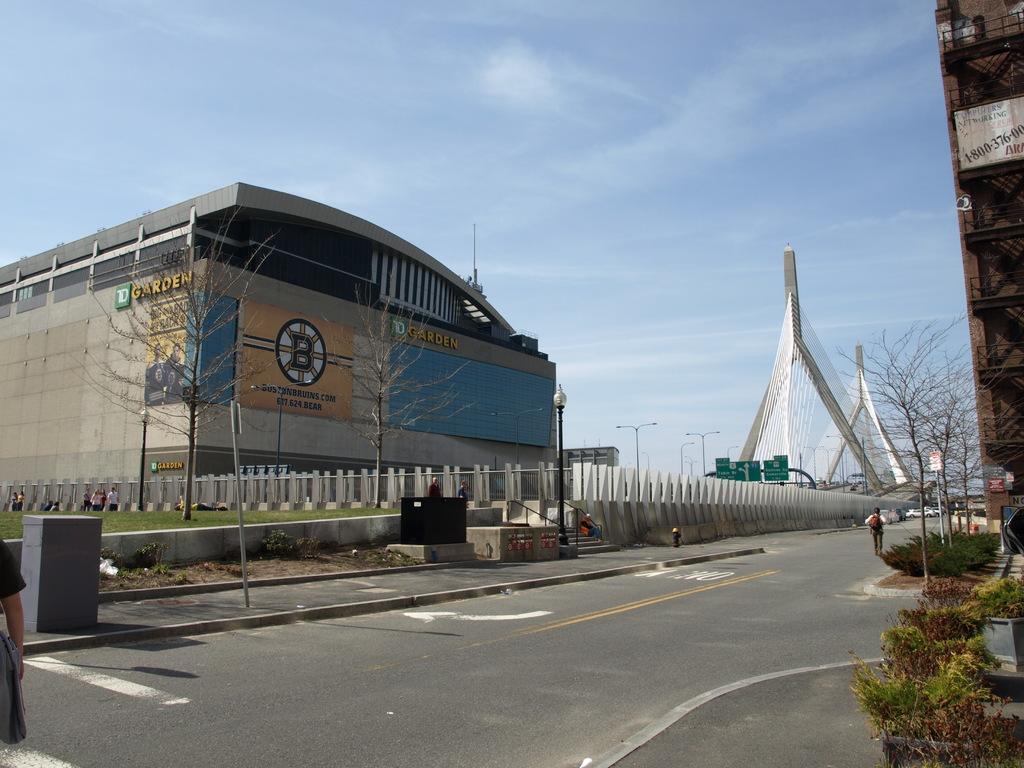Describe this image in one or two sentences. In this image we can see a building and some text written on it, some people in front of the building, a road and a person walking on the road, there are some trees and plants, sign boards and street lights and a sky. 